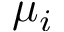Convert formula to latex. <formula><loc_0><loc_0><loc_500><loc_500>\mu _ { i }</formula> 